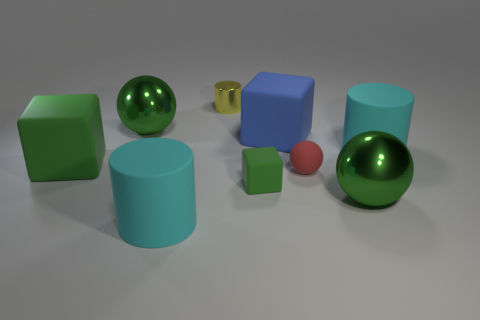There is a matte cylinder that is to the right of the tiny red object; does it have the same color as the rubber cylinder to the left of the small matte cube?
Make the answer very short. Yes. The blue thing is what shape?
Your answer should be compact. Cube. There is a large cyan matte object to the right of the big blue block; what is its shape?
Your response must be concise. Cylinder. Is the size of the blue rubber thing the same as the red ball?
Offer a terse response. No. There is a red object in front of the rubber block that is left of the small yellow cylinder; what is its size?
Provide a succinct answer. Small. There is a matte thing that is in front of the big green matte cube and on the right side of the small green rubber block; what size is it?
Provide a succinct answer. Small. What number of purple cylinders have the same size as the yellow metallic cylinder?
Provide a succinct answer. 0. How many metal objects are small cubes or big cyan objects?
Give a very brief answer. 0. There is another rubber cube that is the same color as the small cube; what is its size?
Your answer should be very brief. Large. What material is the green block in front of the block that is to the left of the yellow metal cylinder?
Your answer should be compact. Rubber. 